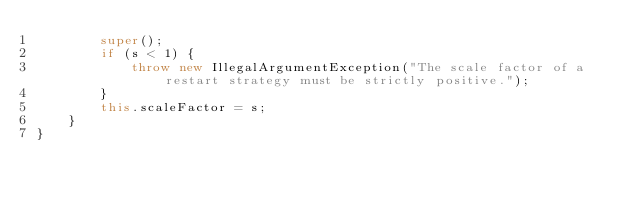<code> <loc_0><loc_0><loc_500><loc_500><_Java_>        super();
        if (s < 1) {
            throw new IllegalArgumentException("The scale factor of a restart strategy must be strictly positive.");
        }
        this.scaleFactor = s;
    }
}
</code> 